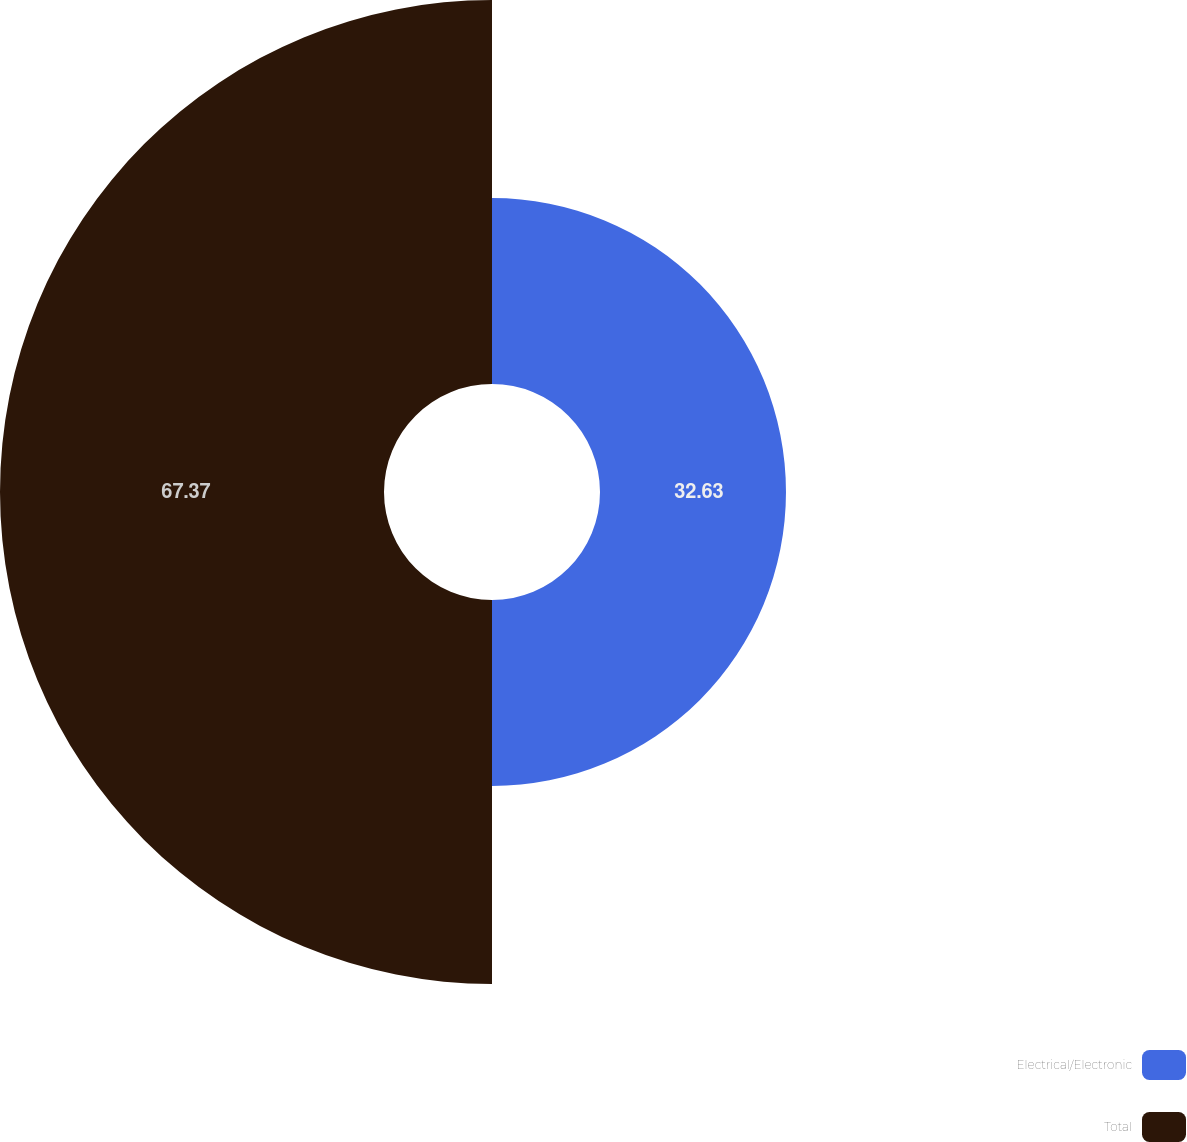Convert chart to OTSL. <chart><loc_0><loc_0><loc_500><loc_500><pie_chart><fcel>Electrical/Electronic<fcel>Total<nl><fcel>32.63%<fcel>67.37%<nl></chart> 